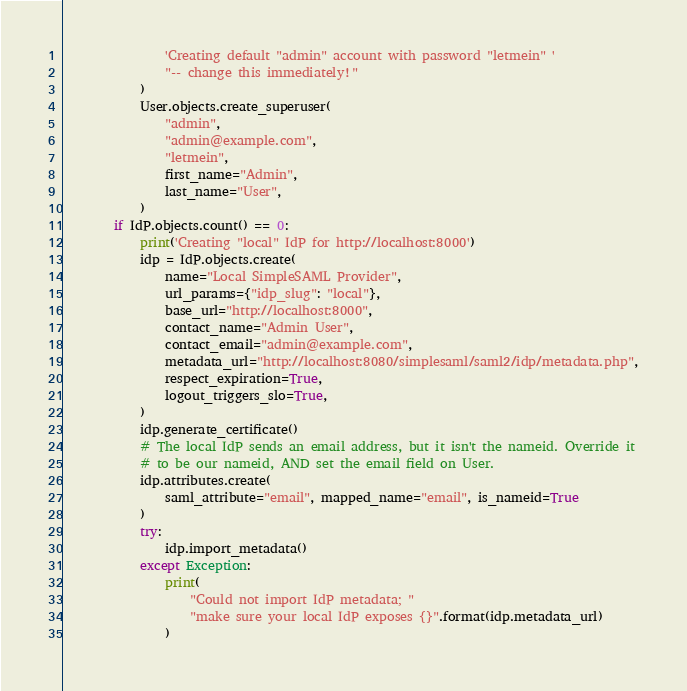Convert code to text. <code><loc_0><loc_0><loc_500><loc_500><_Python_>                'Creating default "admin" account with password "letmein" '
                "-- change this immediately!"
            )
            User.objects.create_superuser(
                "admin",
                "admin@example.com",
                "letmein",
                first_name="Admin",
                last_name="User",
            )
        if IdP.objects.count() == 0:
            print('Creating "local" IdP for http://localhost:8000')
            idp = IdP.objects.create(
                name="Local SimpleSAML Provider",
                url_params={"idp_slug": "local"},
                base_url="http://localhost:8000",
                contact_name="Admin User",
                contact_email="admin@example.com",
                metadata_url="http://localhost:8080/simplesaml/saml2/idp/metadata.php",
                respect_expiration=True,
                logout_triggers_slo=True,
            )
            idp.generate_certificate()
            # The local IdP sends an email address, but it isn't the nameid. Override it
            # to be our nameid, AND set the email field on User.
            idp.attributes.create(
                saml_attribute="email", mapped_name="email", is_nameid=True
            )
            try:
                idp.import_metadata()
            except Exception:
                print(
                    "Could not import IdP metadata; "
                    "make sure your local IdP exposes {}".format(idp.metadata_url)
                )
</code> 